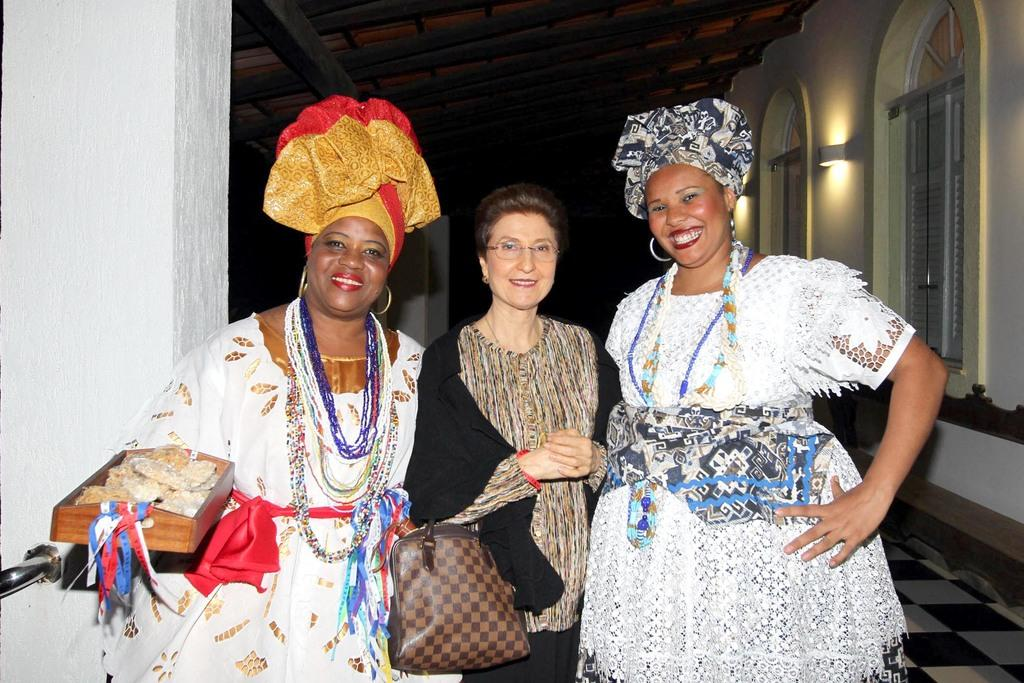How many women are in the image? There are three women in the image. What are the women doing in the image? The women are standing and smiling. Can you describe any accessories the women are holding? One of the women is holding a handbag. What type of wax is being used by the women in the image? There is no wax present in the image; the women are simply standing and smiling. 